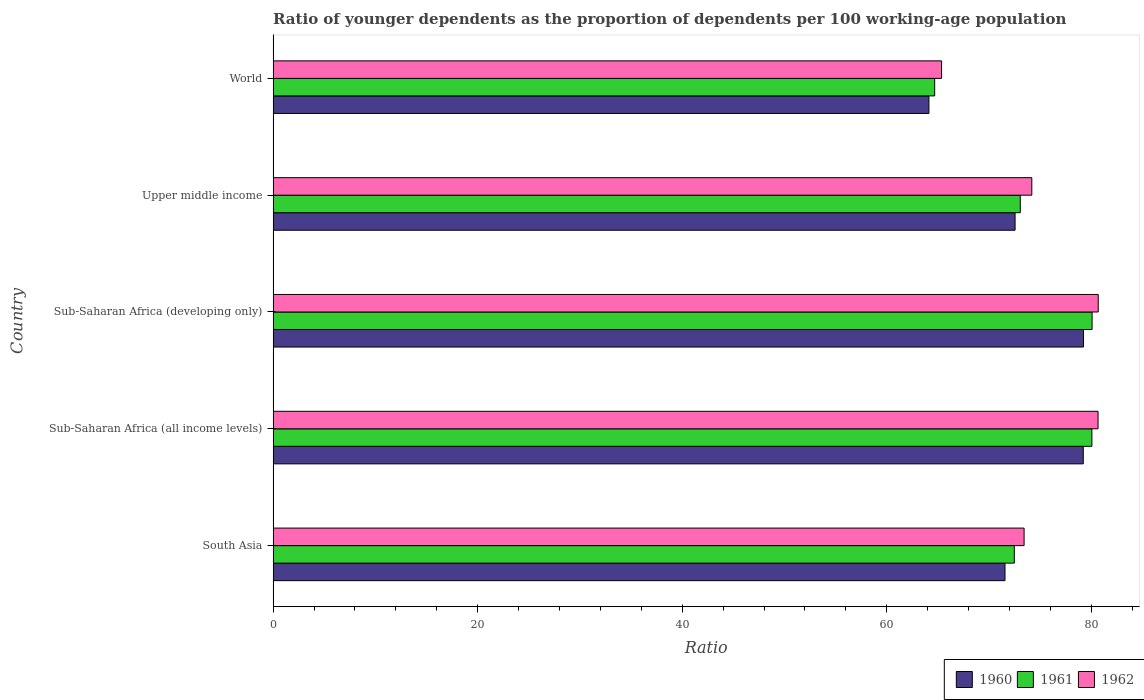How many groups of bars are there?
Your response must be concise. 5. Are the number of bars on each tick of the Y-axis equal?
Your answer should be very brief. Yes. How many bars are there on the 3rd tick from the top?
Ensure brevity in your answer.  3. What is the label of the 3rd group of bars from the top?
Offer a terse response. Sub-Saharan Africa (developing only). In how many cases, is the number of bars for a given country not equal to the number of legend labels?
Ensure brevity in your answer.  0. What is the age dependency ratio(young) in 1960 in Sub-Saharan Africa (developing only)?
Ensure brevity in your answer.  79.23. Across all countries, what is the maximum age dependency ratio(young) in 1960?
Provide a succinct answer. 79.23. Across all countries, what is the minimum age dependency ratio(young) in 1960?
Your response must be concise. 64.12. In which country was the age dependency ratio(young) in 1962 maximum?
Offer a very short reply. Sub-Saharan Africa (developing only). In which country was the age dependency ratio(young) in 1962 minimum?
Ensure brevity in your answer.  World. What is the total age dependency ratio(young) in 1960 in the graph?
Make the answer very short. 366.67. What is the difference between the age dependency ratio(young) in 1961 in South Asia and that in Sub-Saharan Africa (developing only)?
Provide a succinct answer. -7.6. What is the difference between the age dependency ratio(young) in 1961 in Upper middle income and the age dependency ratio(young) in 1962 in Sub-Saharan Africa (all income levels)?
Offer a terse response. -7.6. What is the average age dependency ratio(young) in 1962 per country?
Your response must be concise. 74.86. What is the difference between the age dependency ratio(young) in 1960 and age dependency ratio(young) in 1962 in Sub-Saharan Africa (all income levels)?
Offer a very short reply. -1.44. What is the ratio of the age dependency ratio(young) in 1961 in Sub-Saharan Africa (developing only) to that in World?
Your response must be concise. 1.24. Is the age dependency ratio(young) in 1962 in Sub-Saharan Africa (developing only) less than that in World?
Provide a succinct answer. No. Is the difference between the age dependency ratio(young) in 1960 in Sub-Saharan Africa (all income levels) and Upper middle income greater than the difference between the age dependency ratio(young) in 1962 in Sub-Saharan Africa (all income levels) and Upper middle income?
Offer a terse response. Yes. What is the difference between the highest and the second highest age dependency ratio(young) in 1962?
Keep it short and to the point. 0.02. What is the difference between the highest and the lowest age dependency ratio(young) in 1961?
Provide a succinct answer. 15.39. Is the sum of the age dependency ratio(young) in 1960 in South Asia and Sub-Saharan Africa (developing only) greater than the maximum age dependency ratio(young) in 1961 across all countries?
Offer a very short reply. Yes. What does the 3rd bar from the top in Sub-Saharan Africa (all income levels) represents?
Provide a succinct answer. 1960. What does the 1st bar from the bottom in South Asia represents?
Your response must be concise. 1960. Is it the case that in every country, the sum of the age dependency ratio(young) in 1962 and age dependency ratio(young) in 1960 is greater than the age dependency ratio(young) in 1961?
Give a very brief answer. Yes. How many bars are there?
Offer a terse response. 15. What is the difference between two consecutive major ticks on the X-axis?
Provide a succinct answer. 20. Does the graph contain any zero values?
Offer a very short reply. No. What is the title of the graph?
Your response must be concise. Ratio of younger dependents as the proportion of dependents per 100 working-age population. Does "1977" appear as one of the legend labels in the graph?
Keep it short and to the point. No. What is the label or title of the X-axis?
Offer a terse response. Ratio. What is the label or title of the Y-axis?
Keep it short and to the point. Country. What is the Ratio in 1960 in South Asia?
Make the answer very short. 71.56. What is the Ratio in 1961 in South Asia?
Make the answer very short. 72.47. What is the Ratio of 1962 in South Asia?
Make the answer very short. 73.43. What is the Ratio of 1960 in Sub-Saharan Africa (all income levels)?
Your answer should be very brief. 79.21. What is the Ratio of 1961 in Sub-Saharan Africa (all income levels)?
Make the answer very short. 80.06. What is the Ratio of 1962 in Sub-Saharan Africa (all income levels)?
Your answer should be very brief. 80.66. What is the Ratio in 1960 in Sub-Saharan Africa (developing only)?
Your answer should be compact. 79.23. What is the Ratio in 1961 in Sub-Saharan Africa (developing only)?
Offer a very short reply. 80.07. What is the Ratio in 1962 in Sub-Saharan Africa (developing only)?
Your answer should be compact. 80.68. What is the Ratio in 1960 in Upper middle income?
Give a very brief answer. 72.54. What is the Ratio in 1961 in Upper middle income?
Provide a succinct answer. 73.05. What is the Ratio in 1962 in Upper middle income?
Your response must be concise. 74.18. What is the Ratio in 1960 in World?
Ensure brevity in your answer.  64.12. What is the Ratio in 1961 in World?
Offer a terse response. 64.68. What is the Ratio in 1962 in World?
Offer a terse response. 65.36. Across all countries, what is the maximum Ratio in 1960?
Offer a terse response. 79.23. Across all countries, what is the maximum Ratio in 1961?
Offer a very short reply. 80.07. Across all countries, what is the maximum Ratio of 1962?
Offer a very short reply. 80.68. Across all countries, what is the minimum Ratio of 1960?
Offer a very short reply. 64.12. Across all countries, what is the minimum Ratio of 1961?
Your response must be concise. 64.68. Across all countries, what is the minimum Ratio in 1962?
Ensure brevity in your answer.  65.36. What is the total Ratio of 1960 in the graph?
Keep it short and to the point. 366.67. What is the total Ratio of 1961 in the graph?
Offer a terse response. 370.34. What is the total Ratio in 1962 in the graph?
Give a very brief answer. 374.3. What is the difference between the Ratio of 1960 in South Asia and that in Sub-Saharan Africa (all income levels)?
Your answer should be compact. -7.65. What is the difference between the Ratio of 1961 in South Asia and that in Sub-Saharan Africa (all income levels)?
Offer a terse response. -7.59. What is the difference between the Ratio in 1962 in South Asia and that in Sub-Saharan Africa (all income levels)?
Provide a succinct answer. -7.23. What is the difference between the Ratio of 1960 in South Asia and that in Sub-Saharan Africa (developing only)?
Your answer should be very brief. -7.67. What is the difference between the Ratio in 1961 in South Asia and that in Sub-Saharan Africa (developing only)?
Give a very brief answer. -7.6. What is the difference between the Ratio of 1962 in South Asia and that in Sub-Saharan Africa (developing only)?
Your answer should be compact. -7.25. What is the difference between the Ratio of 1960 in South Asia and that in Upper middle income?
Give a very brief answer. -0.99. What is the difference between the Ratio of 1961 in South Asia and that in Upper middle income?
Keep it short and to the point. -0.58. What is the difference between the Ratio of 1962 in South Asia and that in Upper middle income?
Your answer should be compact. -0.76. What is the difference between the Ratio of 1960 in South Asia and that in World?
Make the answer very short. 7.44. What is the difference between the Ratio of 1961 in South Asia and that in World?
Offer a terse response. 7.79. What is the difference between the Ratio of 1962 in South Asia and that in World?
Offer a terse response. 8.07. What is the difference between the Ratio of 1960 in Sub-Saharan Africa (all income levels) and that in Sub-Saharan Africa (developing only)?
Give a very brief answer. -0.02. What is the difference between the Ratio of 1961 in Sub-Saharan Africa (all income levels) and that in Sub-Saharan Africa (developing only)?
Offer a very short reply. -0.02. What is the difference between the Ratio in 1962 in Sub-Saharan Africa (all income levels) and that in Sub-Saharan Africa (developing only)?
Your answer should be very brief. -0.02. What is the difference between the Ratio in 1960 in Sub-Saharan Africa (all income levels) and that in Upper middle income?
Offer a terse response. 6.67. What is the difference between the Ratio of 1961 in Sub-Saharan Africa (all income levels) and that in Upper middle income?
Ensure brevity in your answer.  7. What is the difference between the Ratio in 1962 in Sub-Saharan Africa (all income levels) and that in Upper middle income?
Provide a short and direct response. 6.48. What is the difference between the Ratio in 1960 in Sub-Saharan Africa (all income levels) and that in World?
Offer a very short reply. 15.09. What is the difference between the Ratio of 1961 in Sub-Saharan Africa (all income levels) and that in World?
Your answer should be very brief. 15.37. What is the difference between the Ratio in 1962 in Sub-Saharan Africa (all income levels) and that in World?
Give a very brief answer. 15.3. What is the difference between the Ratio in 1960 in Sub-Saharan Africa (developing only) and that in Upper middle income?
Ensure brevity in your answer.  6.69. What is the difference between the Ratio in 1961 in Sub-Saharan Africa (developing only) and that in Upper middle income?
Give a very brief answer. 7.02. What is the difference between the Ratio of 1962 in Sub-Saharan Africa (developing only) and that in Upper middle income?
Make the answer very short. 6.49. What is the difference between the Ratio in 1960 in Sub-Saharan Africa (developing only) and that in World?
Your answer should be compact. 15.11. What is the difference between the Ratio of 1961 in Sub-Saharan Africa (developing only) and that in World?
Offer a very short reply. 15.39. What is the difference between the Ratio in 1962 in Sub-Saharan Africa (developing only) and that in World?
Provide a succinct answer. 15.32. What is the difference between the Ratio of 1960 in Upper middle income and that in World?
Ensure brevity in your answer.  8.42. What is the difference between the Ratio of 1961 in Upper middle income and that in World?
Keep it short and to the point. 8.37. What is the difference between the Ratio of 1962 in Upper middle income and that in World?
Offer a very short reply. 8.82. What is the difference between the Ratio of 1960 in South Asia and the Ratio of 1961 in Sub-Saharan Africa (all income levels)?
Ensure brevity in your answer.  -8.5. What is the difference between the Ratio of 1960 in South Asia and the Ratio of 1962 in Sub-Saharan Africa (all income levels)?
Ensure brevity in your answer.  -9.1. What is the difference between the Ratio in 1961 in South Asia and the Ratio in 1962 in Sub-Saharan Africa (all income levels)?
Offer a very short reply. -8.19. What is the difference between the Ratio in 1960 in South Asia and the Ratio in 1961 in Sub-Saharan Africa (developing only)?
Your answer should be compact. -8.52. What is the difference between the Ratio of 1960 in South Asia and the Ratio of 1962 in Sub-Saharan Africa (developing only)?
Your answer should be very brief. -9.12. What is the difference between the Ratio of 1961 in South Asia and the Ratio of 1962 in Sub-Saharan Africa (developing only)?
Keep it short and to the point. -8.21. What is the difference between the Ratio in 1960 in South Asia and the Ratio in 1961 in Upper middle income?
Make the answer very short. -1.49. What is the difference between the Ratio in 1960 in South Asia and the Ratio in 1962 in Upper middle income?
Your answer should be compact. -2.62. What is the difference between the Ratio of 1961 in South Asia and the Ratio of 1962 in Upper middle income?
Your answer should be very brief. -1.71. What is the difference between the Ratio of 1960 in South Asia and the Ratio of 1961 in World?
Provide a short and direct response. 6.88. What is the difference between the Ratio in 1960 in South Asia and the Ratio in 1962 in World?
Your answer should be compact. 6.2. What is the difference between the Ratio of 1961 in South Asia and the Ratio of 1962 in World?
Provide a succinct answer. 7.11. What is the difference between the Ratio of 1960 in Sub-Saharan Africa (all income levels) and the Ratio of 1961 in Sub-Saharan Africa (developing only)?
Provide a succinct answer. -0.86. What is the difference between the Ratio of 1960 in Sub-Saharan Africa (all income levels) and the Ratio of 1962 in Sub-Saharan Africa (developing only)?
Offer a very short reply. -1.46. What is the difference between the Ratio in 1961 in Sub-Saharan Africa (all income levels) and the Ratio in 1962 in Sub-Saharan Africa (developing only)?
Make the answer very short. -0.62. What is the difference between the Ratio in 1960 in Sub-Saharan Africa (all income levels) and the Ratio in 1961 in Upper middle income?
Your answer should be compact. 6.16. What is the difference between the Ratio of 1960 in Sub-Saharan Africa (all income levels) and the Ratio of 1962 in Upper middle income?
Ensure brevity in your answer.  5.03. What is the difference between the Ratio in 1961 in Sub-Saharan Africa (all income levels) and the Ratio in 1962 in Upper middle income?
Offer a very short reply. 5.87. What is the difference between the Ratio of 1960 in Sub-Saharan Africa (all income levels) and the Ratio of 1961 in World?
Your answer should be compact. 14.53. What is the difference between the Ratio of 1960 in Sub-Saharan Africa (all income levels) and the Ratio of 1962 in World?
Offer a very short reply. 13.86. What is the difference between the Ratio in 1961 in Sub-Saharan Africa (all income levels) and the Ratio in 1962 in World?
Offer a very short reply. 14.7. What is the difference between the Ratio in 1960 in Sub-Saharan Africa (developing only) and the Ratio in 1961 in Upper middle income?
Your answer should be compact. 6.18. What is the difference between the Ratio of 1960 in Sub-Saharan Africa (developing only) and the Ratio of 1962 in Upper middle income?
Your response must be concise. 5.05. What is the difference between the Ratio of 1961 in Sub-Saharan Africa (developing only) and the Ratio of 1962 in Upper middle income?
Your answer should be very brief. 5.89. What is the difference between the Ratio in 1960 in Sub-Saharan Africa (developing only) and the Ratio in 1961 in World?
Your answer should be compact. 14.55. What is the difference between the Ratio of 1960 in Sub-Saharan Africa (developing only) and the Ratio of 1962 in World?
Provide a short and direct response. 13.88. What is the difference between the Ratio in 1961 in Sub-Saharan Africa (developing only) and the Ratio in 1962 in World?
Offer a terse response. 14.72. What is the difference between the Ratio of 1960 in Upper middle income and the Ratio of 1961 in World?
Your answer should be very brief. 7.86. What is the difference between the Ratio of 1960 in Upper middle income and the Ratio of 1962 in World?
Your answer should be compact. 7.19. What is the difference between the Ratio in 1961 in Upper middle income and the Ratio in 1962 in World?
Offer a terse response. 7.7. What is the average Ratio of 1960 per country?
Offer a very short reply. 73.33. What is the average Ratio in 1961 per country?
Your answer should be very brief. 74.07. What is the average Ratio of 1962 per country?
Offer a terse response. 74.86. What is the difference between the Ratio in 1960 and Ratio in 1961 in South Asia?
Your response must be concise. -0.91. What is the difference between the Ratio of 1960 and Ratio of 1962 in South Asia?
Offer a terse response. -1.87. What is the difference between the Ratio of 1961 and Ratio of 1962 in South Asia?
Ensure brevity in your answer.  -0.96. What is the difference between the Ratio in 1960 and Ratio in 1961 in Sub-Saharan Africa (all income levels)?
Give a very brief answer. -0.84. What is the difference between the Ratio in 1960 and Ratio in 1962 in Sub-Saharan Africa (all income levels)?
Your response must be concise. -1.44. What is the difference between the Ratio of 1961 and Ratio of 1962 in Sub-Saharan Africa (all income levels)?
Provide a short and direct response. -0.6. What is the difference between the Ratio of 1960 and Ratio of 1961 in Sub-Saharan Africa (developing only)?
Keep it short and to the point. -0.84. What is the difference between the Ratio of 1960 and Ratio of 1962 in Sub-Saharan Africa (developing only)?
Your response must be concise. -1.44. What is the difference between the Ratio in 1961 and Ratio in 1962 in Sub-Saharan Africa (developing only)?
Offer a very short reply. -0.6. What is the difference between the Ratio in 1960 and Ratio in 1961 in Upper middle income?
Your answer should be compact. -0.51. What is the difference between the Ratio in 1960 and Ratio in 1962 in Upper middle income?
Provide a short and direct response. -1.64. What is the difference between the Ratio in 1961 and Ratio in 1962 in Upper middle income?
Offer a very short reply. -1.13. What is the difference between the Ratio in 1960 and Ratio in 1961 in World?
Your answer should be very brief. -0.56. What is the difference between the Ratio of 1960 and Ratio of 1962 in World?
Your answer should be very brief. -1.24. What is the difference between the Ratio in 1961 and Ratio in 1962 in World?
Give a very brief answer. -0.67. What is the ratio of the Ratio in 1960 in South Asia to that in Sub-Saharan Africa (all income levels)?
Provide a succinct answer. 0.9. What is the ratio of the Ratio of 1961 in South Asia to that in Sub-Saharan Africa (all income levels)?
Offer a very short reply. 0.91. What is the ratio of the Ratio of 1962 in South Asia to that in Sub-Saharan Africa (all income levels)?
Provide a succinct answer. 0.91. What is the ratio of the Ratio of 1960 in South Asia to that in Sub-Saharan Africa (developing only)?
Your answer should be compact. 0.9. What is the ratio of the Ratio of 1961 in South Asia to that in Sub-Saharan Africa (developing only)?
Keep it short and to the point. 0.91. What is the ratio of the Ratio of 1962 in South Asia to that in Sub-Saharan Africa (developing only)?
Offer a terse response. 0.91. What is the ratio of the Ratio in 1960 in South Asia to that in Upper middle income?
Keep it short and to the point. 0.99. What is the ratio of the Ratio in 1961 in South Asia to that in Upper middle income?
Your response must be concise. 0.99. What is the ratio of the Ratio in 1962 in South Asia to that in Upper middle income?
Offer a terse response. 0.99. What is the ratio of the Ratio in 1960 in South Asia to that in World?
Provide a short and direct response. 1.12. What is the ratio of the Ratio of 1961 in South Asia to that in World?
Provide a succinct answer. 1.12. What is the ratio of the Ratio in 1962 in South Asia to that in World?
Make the answer very short. 1.12. What is the ratio of the Ratio of 1960 in Sub-Saharan Africa (all income levels) to that in Sub-Saharan Africa (developing only)?
Make the answer very short. 1. What is the ratio of the Ratio of 1960 in Sub-Saharan Africa (all income levels) to that in Upper middle income?
Ensure brevity in your answer.  1.09. What is the ratio of the Ratio of 1961 in Sub-Saharan Africa (all income levels) to that in Upper middle income?
Your answer should be compact. 1.1. What is the ratio of the Ratio of 1962 in Sub-Saharan Africa (all income levels) to that in Upper middle income?
Make the answer very short. 1.09. What is the ratio of the Ratio of 1960 in Sub-Saharan Africa (all income levels) to that in World?
Ensure brevity in your answer.  1.24. What is the ratio of the Ratio in 1961 in Sub-Saharan Africa (all income levels) to that in World?
Give a very brief answer. 1.24. What is the ratio of the Ratio of 1962 in Sub-Saharan Africa (all income levels) to that in World?
Your answer should be compact. 1.23. What is the ratio of the Ratio of 1960 in Sub-Saharan Africa (developing only) to that in Upper middle income?
Your answer should be compact. 1.09. What is the ratio of the Ratio in 1961 in Sub-Saharan Africa (developing only) to that in Upper middle income?
Offer a very short reply. 1.1. What is the ratio of the Ratio in 1962 in Sub-Saharan Africa (developing only) to that in Upper middle income?
Offer a terse response. 1.09. What is the ratio of the Ratio in 1960 in Sub-Saharan Africa (developing only) to that in World?
Ensure brevity in your answer.  1.24. What is the ratio of the Ratio in 1961 in Sub-Saharan Africa (developing only) to that in World?
Make the answer very short. 1.24. What is the ratio of the Ratio in 1962 in Sub-Saharan Africa (developing only) to that in World?
Make the answer very short. 1.23. What is the ratio of the Ratio of 1960 in Upper middle income to that in World?
Keep it short and to the point. 1.13. What is the ratio of the Ratio in 1961 in Upper middle income to that in World?
Keep it short and to the point. 1.13. What is the ratio of the Ratio in 1962 in Upper middle income to that in World?
Your answer should be compact. 1.14. What is the difference between the highest and the second highest Ratio in 1960?
Provide a succinct answer. 0.02. What is the difference between the highest and the second highest Ratio of 1961?
Your answer should be compact. 0.02. What is the difference between the highest and the second highest Ratio in 1962?
Offer a very short reply. 0.02. What is the difference between the highest and the lowest Ratio of 1960?
Give a very brief answer. 15.11. What is the difference between the highest and the lowest Ratio in 1961?
Keep it short and to the point. 15.39. What is the difference between the highest and the lowest Ratio in 1962?
Your response must be concise. 15.32. 